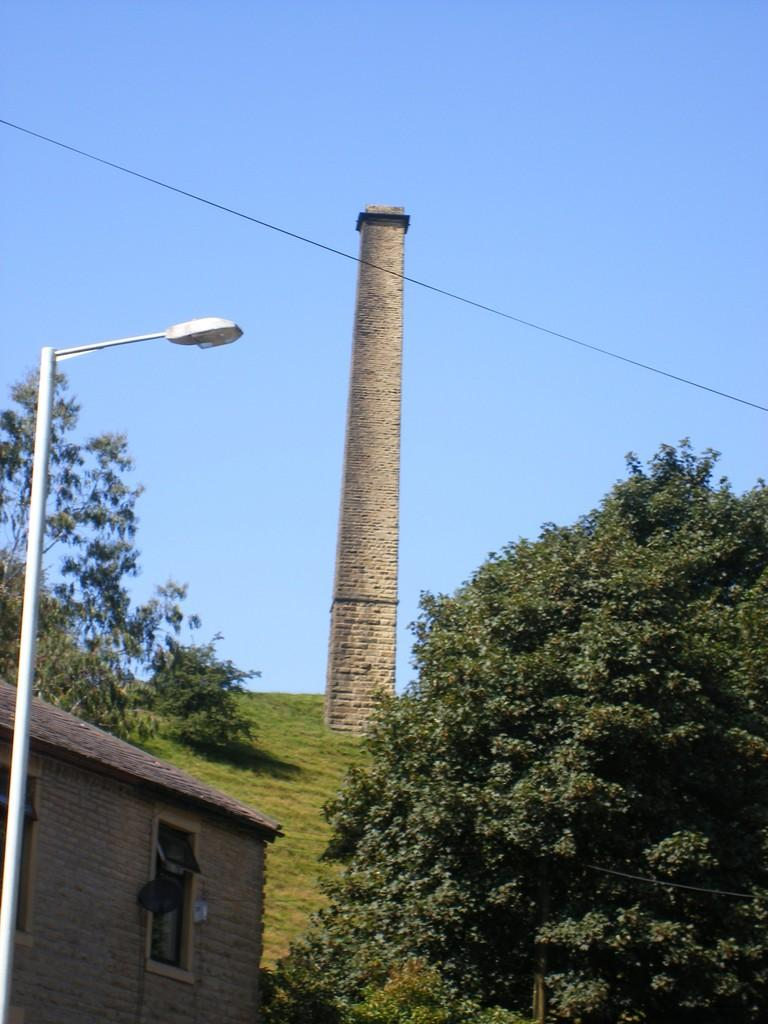What is the main structure in the image? There is a tower in the image. What type of vegetation can be seen in the image? There are trees in the image. What type of building is present in the image? There is a shed in the image. What communication-related object is visible in the image? There is an antenna in the image. What type of pole is present in the image? There is a street pole in the image. What type of lighting is present in the image? There is a street light in the image. What type of infrastructure is visible in the image? There is a cable in the image. What part of the natural environment is visible in the image? The sky is visible in the image. How many babies are playing in the water near the tower in the image? There are no babies or water present in the image. What type of bird can be seen flying near the tower in the image? There are no birds present in the image. 